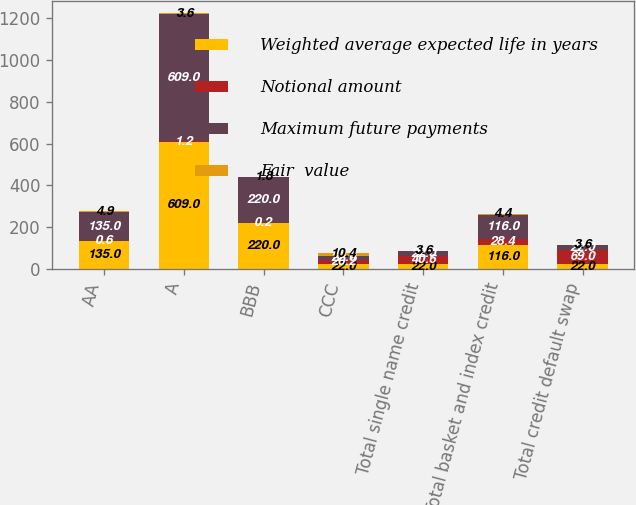<chart> <loc_0><loc_0><loc_500><loc_500><stacked_bar_chart><ecel><fcel>AA<fcel>A<fcel>BBB<fcel>CCC<fcel>Total single name credit<fcel>Total basket and index credit<fcel>Total credit default swap<nl><fcel>Weighted average expected life in years<fcel>135<fcel>609<fcel>220<fcel>22<fcel>22<fcel>116<fcel>22<nl><fcel>Notional amount<fcel>0.6<fcel>1.2<fcel>0.2<fcel>20.2<fcel>40.6<fcel>28.4<fcel>69<nl><fcel>Maximum future payments<fcel>135<fcel>609<fcel>220<fcel>22<fcel>22<fcel>116<fcel>22<nl><fcel>Fair  value<fcel>4.9<fcel>3.6<fcel>1.8<fcel>10.4<fcel>3.6<fcel>4.4<fcel>3.6<nl></chart> 